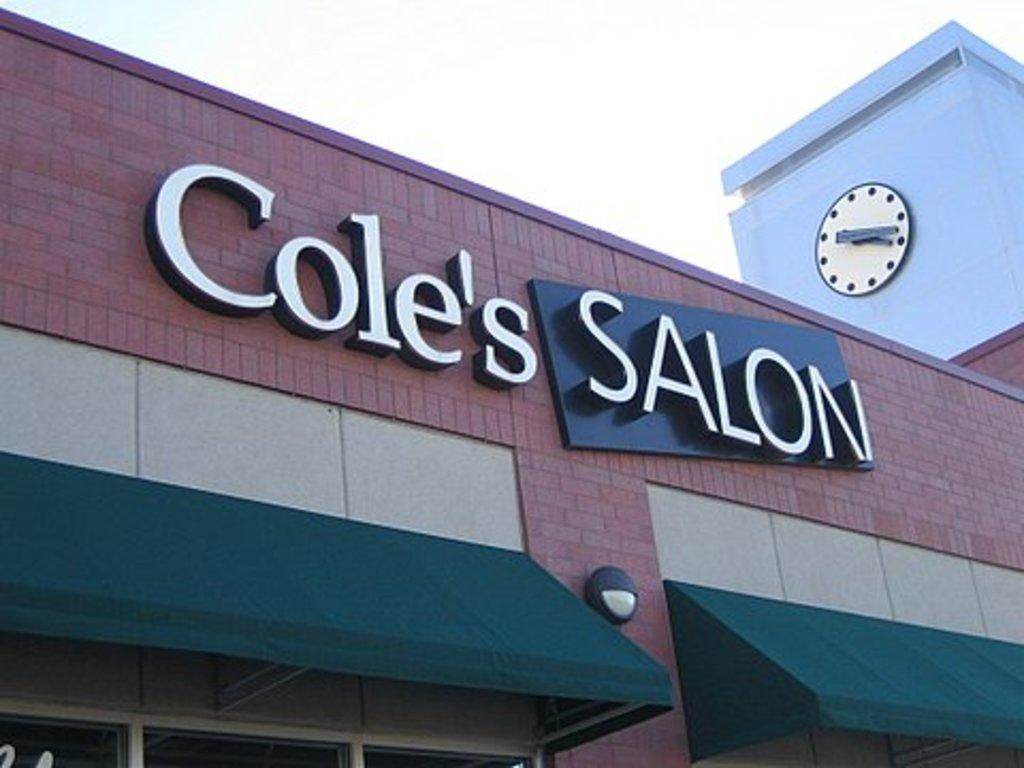<image>
Summarize the visual content of the image. the outside of a brown and beige building with 'cole's salon' displayed on the outside 